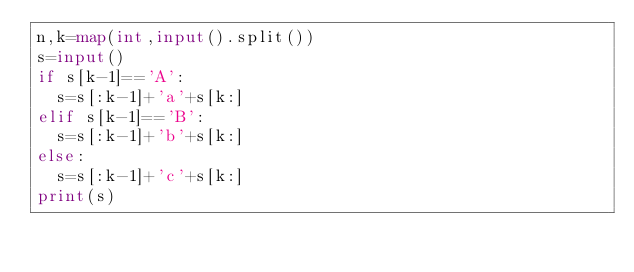Convert code to text. <code><loc_0><loc_0><loc_500><loc_500><_Python_>n,k=map(int,input().split())
s=input()
if s[k-1]=='A':
  s=s[:k-1]+'a'+s[k:]
elif s[k-1]=='B':
  s=s[:k-1]+'b'+s[k:]
else:
  s=s[:k-1]+'c'+s[k:]
print(s)</code> 